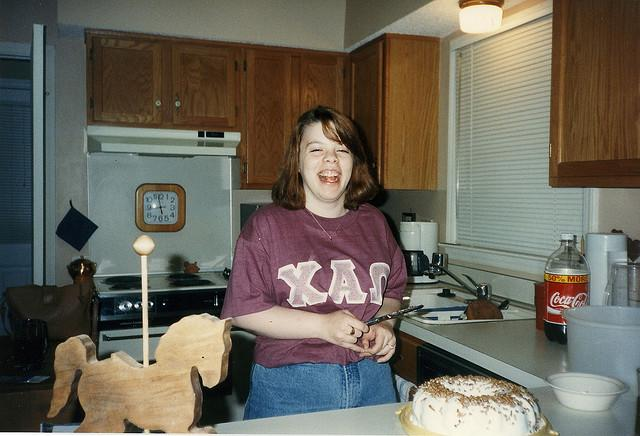What soda does she like to drink?

Choices:
A) fanta
B) coca-cola
C) sprite
D) mountain dew coca-cola 